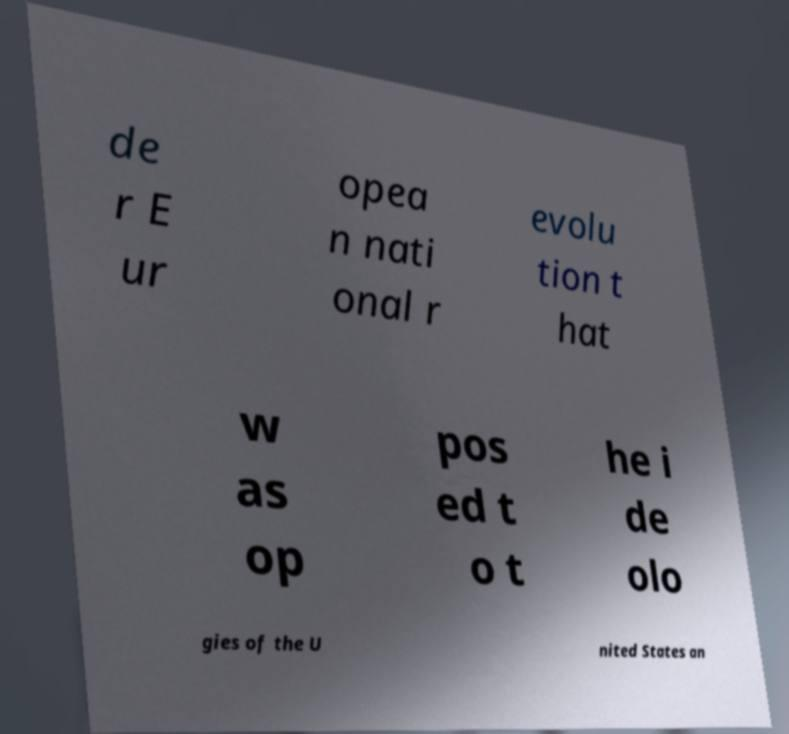Can you accurately transcribe the text from the provided image for me? de r E ur opea n nati onal r evolu tion t hat w as op pos ed t o t he i de olo gies of the U nited States an 